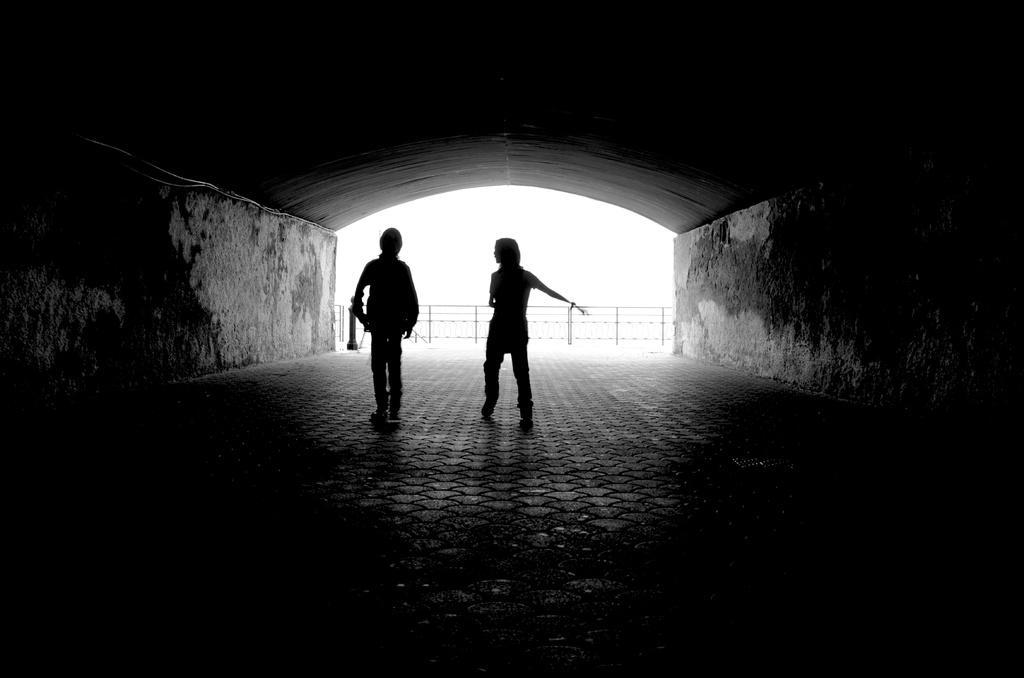Describe this image in one or two sentences. This image is a black and white image. This image is taken outdoors. At the bottom of the image there is a floor. In the middle of the image two persons are standing on the floor. In the background there is a railing. On the left and right sides of the image there are two walls. At the top of the image there is a roof. 